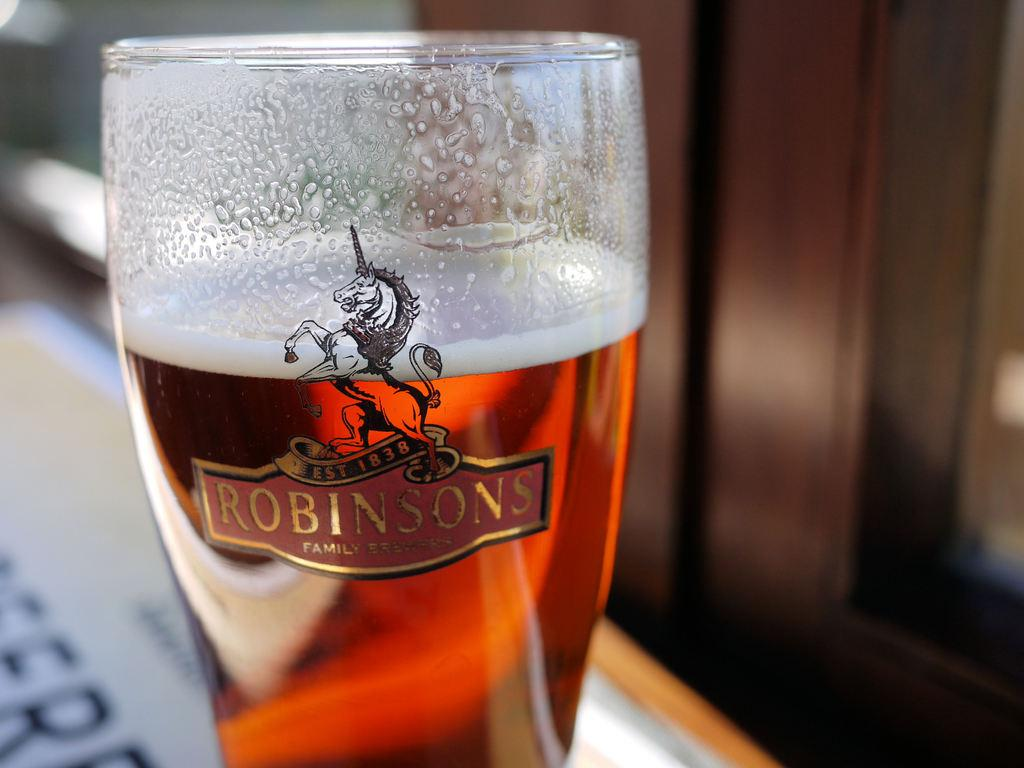Provide a one-sentence caption for the provided image. A glass, which bears the Robinsons logo, is full of liquid. 